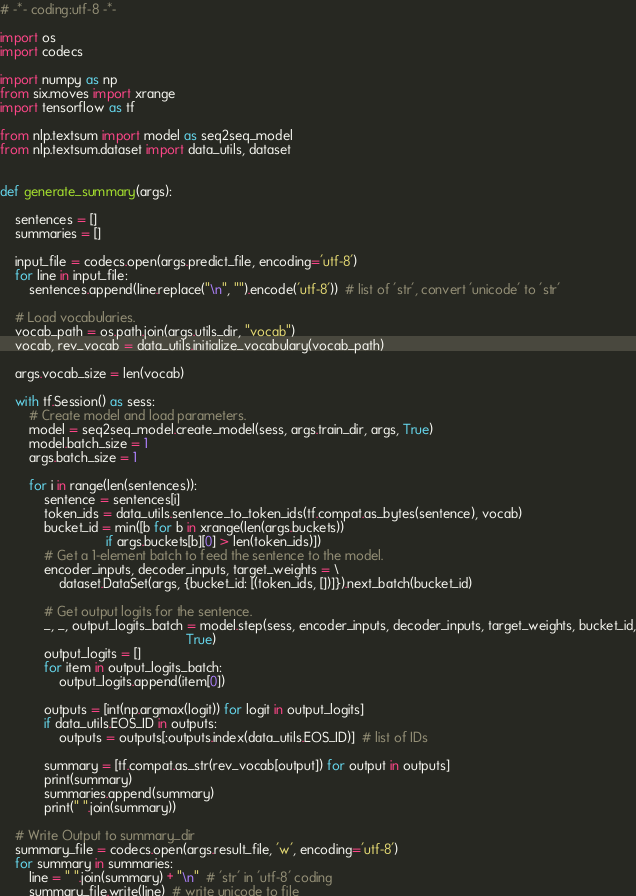<code> <loc_0><loc_0><loc_500><loc_500><_Python_># -*- coding:utf-8 -*-

import os
import codecs

import numpy as np
from six.moves import xrange
import tensorflow as tf

from nlp.textsum import model as seq2seq_model
from nlp.textsum.dataset import data_utils, dataset


def generate_summary(args):

    sentences = []
    summaries = []

    input_file = codecs.open(args.predict_file, encoding='utf-8')
    for line in input_file:
        sentences.append(line.replace("\n", "").encode('utf-8'))  # list of 'str', convert 'unicode' to 'str'

    # Load vocabularies.
    vocab_path = os.path.join(args.utils_dir, "vocab")
    vocab, rev_vocab = data_utils.initialize_vocabulary(vocab_path)

    args.vocab_size = len(vocab)

    with tf.Session() as sess:
        # Create model and load parameters.
        model = seq2seq_model.create_model(sess, args.train_dir, args, True)
        model.batch_size = 1
        args.batch_size = 1

        for i in range(len(sentences)):
            sentence = sentences[i]
            token_ids = data_utils.sentence_to_token_ids(tf.compat.as_bytes(sentence), vocab)
            bucket_id = min([b for b in xrange(len(args.buckets))
                             if args.buckets[b][0] > len(token_ids)])
            # Get a 1-element batch to feed the sentence to the model.
            encoder_inputs, decoder_inputs, target_weights = \
                dataset.DataSet(args, {bucket_id: [(token_ids, [])]}).next_batch(bucket_id)

            # Get output logits for the sentence.
            _, _, output_logits_batch = model.step(sess, encoder_inputs, decoder_inputs, target_weights, bucket_id,
                                                   True)
            output_logits = []
            for item in output_logits_batch:
                output_logits.append(item[0])

            outputs = [int(np.argmax(logit)) for logit in output_logits]
            if data_utils.EOS_ID in outputs:
                outputs = outputs[:outputs.index(data_utils.EOS_ID)]  # list of IDs

            summary = [tf.compat.as_str(rev_vocab[output]) for output in outputs]
            print(summary)
            summaries.append(summary)
            print(" ".join(summary))

    # Write Output to summary_dir
    summary_file = codecs.open(args.result_file, 'w', encoding='utf-8')
    for summary in summaries:
        line = " ".join(summary) + "\n"  # 'str' in 'utf-8' coding
        summary_file.write(line)  # write unicode to file</code> 